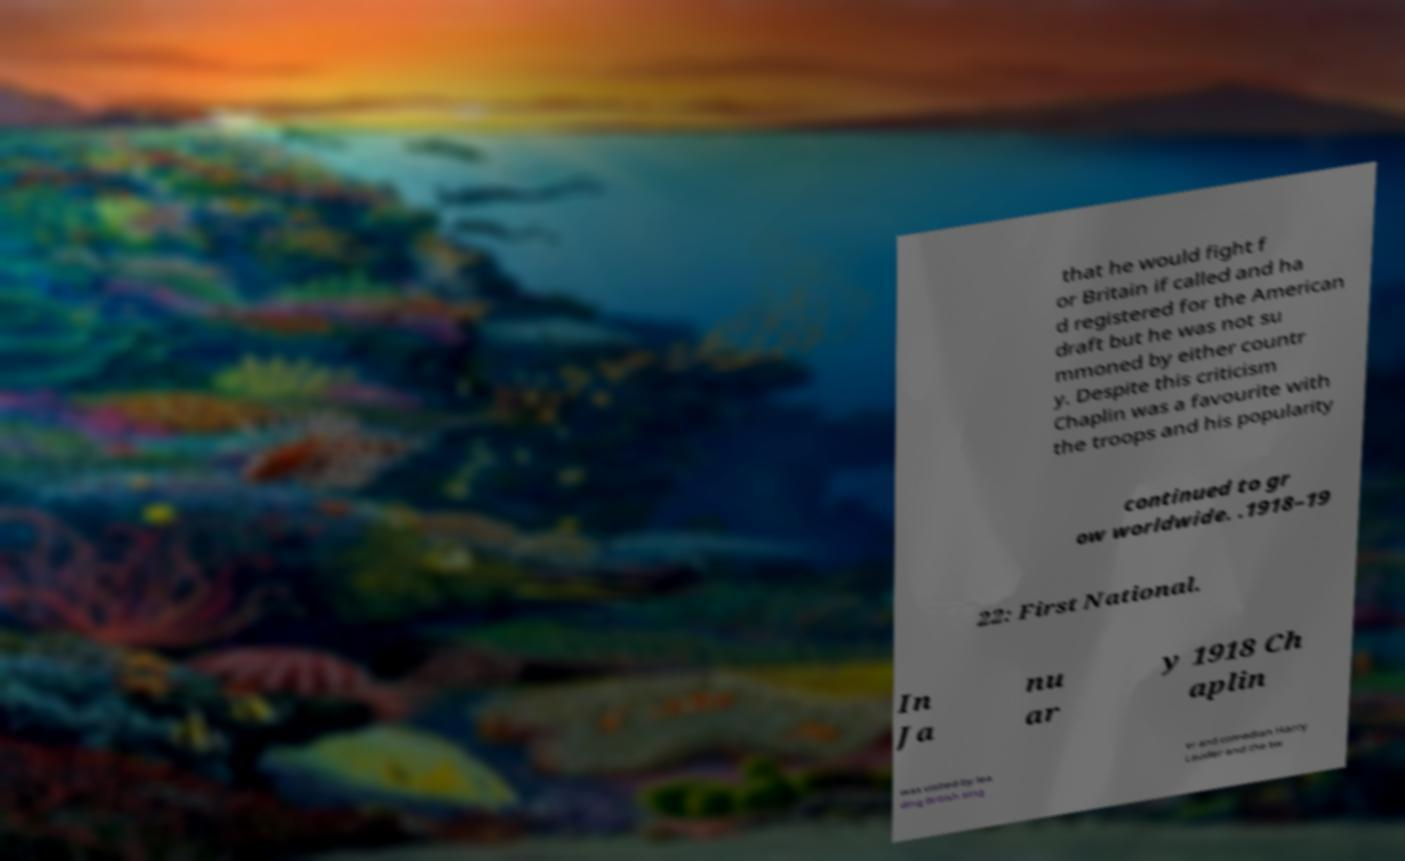For documentation purposes, I need the text within this image transcribed. Could you provide that? that he would fight f or Britain if called and ha d registered for the American draft but he was not su mmoned by either countr y. Despite this criticism Chaplin was a favourite with the troops and his popularity continued to gr ow worldwide. .1918–19 22: First National. In Ja nu ar y 1918 Ch aplin was visited by lea ding British sing er and comedian Harry Lauder and the tw 